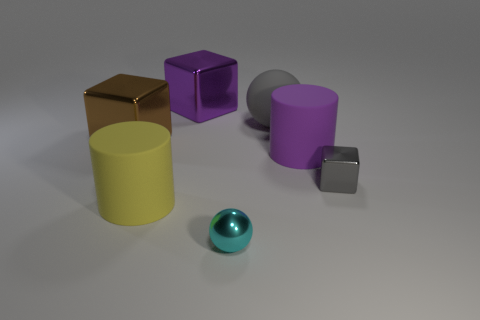Add 1 big purple metal objects. How many objects exist? 8 Subtract all cylinders. How many objects are left? 5 Add 2 big brown shiny things. How many big brown shiny things exist? 3 Subtract 0 gray cylinders. How many objects are left? 7 Subtract all red spheres. Subtract all large gray rubber objects. How many objects are left? 6 Add 1 tiny cyan objects. How many tiny cyan objects are left? 2 